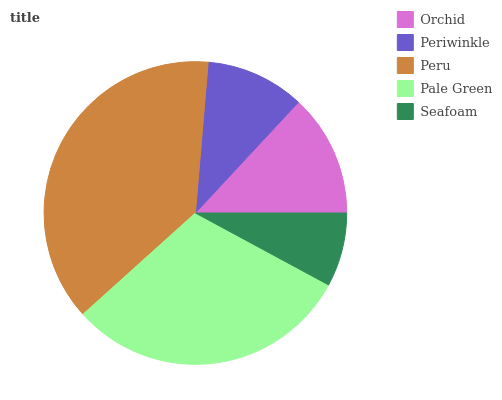Is Seafoam the minimum?
Answer yes or no. Yes. Is Peru the maximum?
Answer yes or no. Yes. Is Periwinkle the minimum?
Answer yes or no. No. Is Periwinkle the maximum?
Answer yes or no. No. Is Orchid greater than Periwinkle?
Answer yes or no. Yes. Is Periwinkle less than Orchid?
Answer yes or no. Yes. Is Periwinkle greater than Orchid?
Answer yes or no. No. Is Orchid less than Periwinkle?
Answer yes or no. No. Is Orchid the high median?
Answer yes or no. Yes. Is Orchid the low median?
Answer yes or no. Yes. Is Periwinkle the high median?
Answer yes or no. No. Is Seafoam the low median?
Answer yes or no. No. 